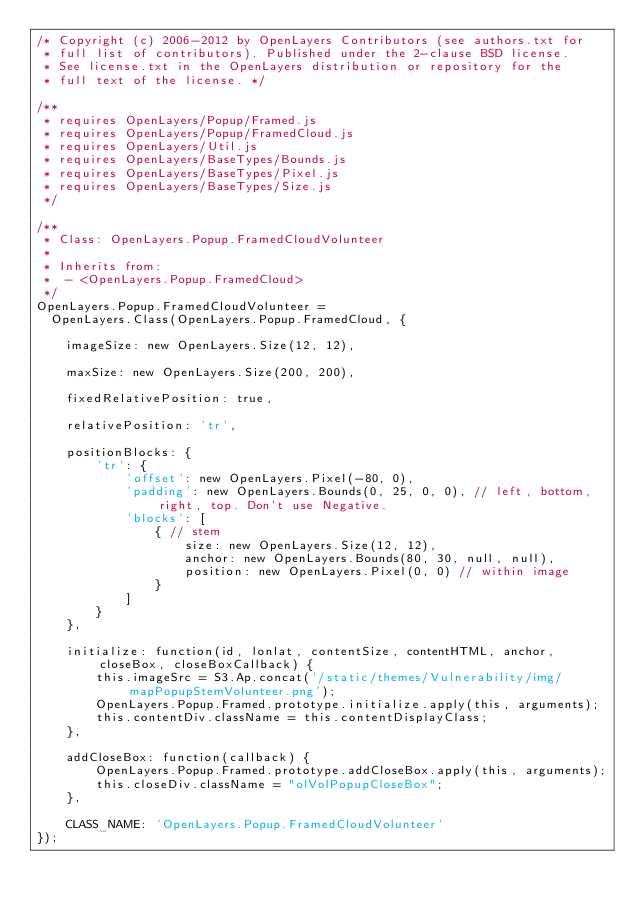Convert code to text. <code><loc_0><loc_0><loc_500><loc_500><_JavaScript_>/* Copyright (c) 2006-2012 by OpenLayers Contributors (see authors.txt for 
 * full list of contributors). Published under the 2-clause BSD license.
 * See license.txt in the OpenLayers distribution or repository for the
 * full text of the license. */

/**
 * requires OpenLayers/Popup/Framed.js
 * requires OpenLayers/Popup/FramedCloud.js
 * requires OpenLayers/Util.js
 * requires OpenLayers/BaseTypes/Bounds.js
 * requires OpenLayers/BaseTypes/Pixel.js
 * requires OpenLayers/BaseTypes/Size.js
 */

/**
 * Class: OpenLayers.Popup.FramedCloudVolunteer
 * 
 * Inherits from: 
 *  - <OpenLayers.Popup.FramedCloud>
 */
OpenLayers.Popup.FramedCloudVolunteer = 
  OpenLayers.Class(OpenLayers.Popup.FramedCloud, {

    imageSize: new OpenLayers.Size(12, 12),

    maxSize: new OpenLayers.Size(200, 200),

    fixedRelativePosition: true,

    relativePosition: 'tr',

    positionBlocks: {
        'tr': {
            'offset': new OpenLayers.Pixel(-80, 0),
            'padding': new OpenLayers.Bounds(0, 25, 0, 0), // left, bottom, right, top. Don't use Negative.
            'blocks': [
                { // stem
                    size: new OpenLayers.Size(12, 12),
                    anchor: new OpenLayers.Bounds(80, 30, null, null),
                    position: new OpenLayers.Pixel(0, 0) // within image
                }
            ]
        }
    },

    initialize: function(id, lonlat, contentSize, contentHTML, anchor, closeBox, closeBoxCallback) {
        this.imageSrc = S3.Ap.concat('/static/themes/Vulnerability/img/mapPopupStemVolunteer.png');
        OpenLayers.Popup.Framed.prototype.initialize.apply(this, arguments);
        this.contentDiv.className = this.contentDisplayClass;
    },

    addCloseBox: function(callback) {
        OpenLayers.Popup.Framed.prototype.addCloseBox.apply(this, arguments);
        this.closeDiv.className = "olVolPopupCloseBox";
    },

    CLASS_NAME: 'OpenLayers.Popup.FramedCloudVolunteer'
});
</code> 